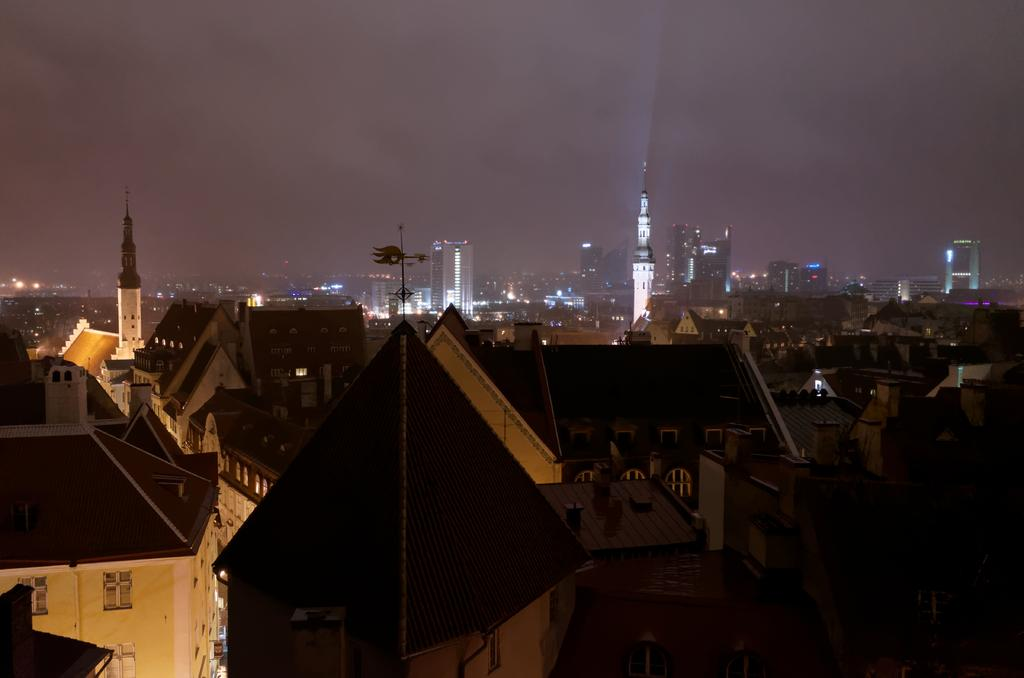At what time of day was the image captured? The image was captured during night time. What can be seen in the sky in the image? The sky is visible in the image. What type of structures are present in the image? Skyscrapers, buildings, and towers are visible in the image. What features of the structures are visible in the image? Windows, lights, and roof tops are visible in the image. What type of music can be heard coming from the snail in the image? There is no snail present in the image, and therefore no music can be heard coming from it. 